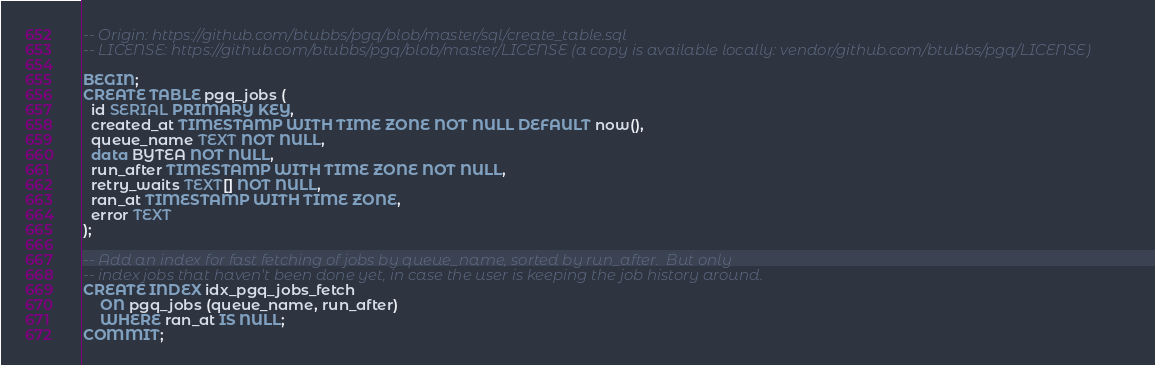Convert code to text. <code><loc_0><loc_0><loc_500><loc_500><_SQL_>-- Origin: https://github.com/btubbs/pgq/blob/master/sql/create_table.sql
-- LICENSE: https://github.com/btubbs/pgq/blob/master/LICENSE (a copy is available locally: vendor/github.com/btubbs/pgq/LICENSE)

BEGIN;
CREATE TABLE pgq_jobs (
  id SERIAL PRIMARY KEY,
  created_at TIMESTAMP WITH TIME ZONE NOT NULL DEFAULT now(),
  queue_name TEXT NOT NULL,
  data BYTEA NOT NULL,
  run_after TIMESTAMP WITH TIME ZONE NOT NULL,
  retry_waits TEXT[] NOT NULL,
  ran_at TIMESTAMP WITH TIME ZONE,
  error TEXT
);

-- Add an index for fast fetching of jobs by queue_name, sorted by run_after.  But only
-- index jobs that haven't been done yet, in case the user is keeping the job history around.
CREATE INDEX idx_pgq_jobs_fetch
	ON pgq_jobs (queue_name, run_after)
	WHERE ran_at IS NULL;
COMMIT;</code> 